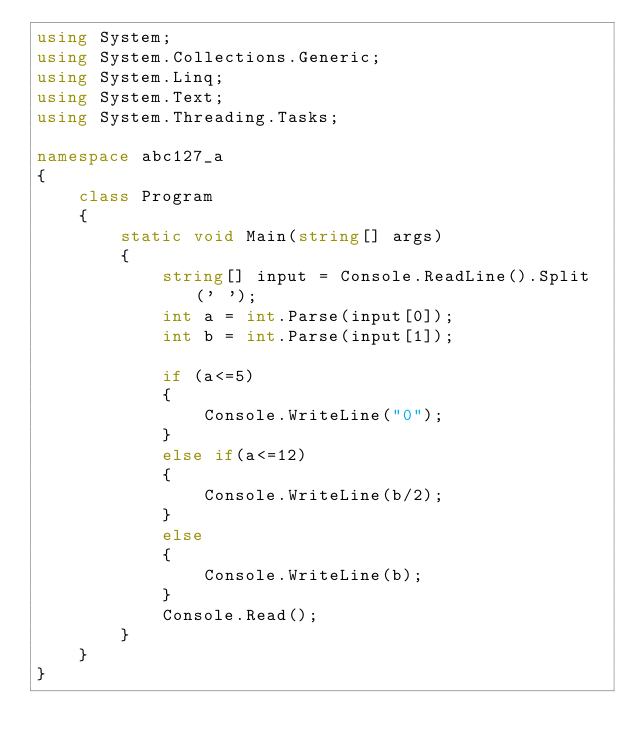<code> <loc_0><loc_0><loc_500><loc_500><_C#_>using System;
using System.Collections.Generic;
using System.Linq;
using System.Text;
using System.Threading.Tasks;

namespace abc127_a
{
    class Program
    {
        static void Main(string[] args)
        {         
            string[] input = Console.ReadLine().Split(' ');
            int a = int.Parse(input[0]);
            int b = int.Parse(input[1]);

            if (a<=5)
            {
                Console.WriteLine("0");
            }
            else if(a<=12)
            {
                Console.WriteLine(b/2);
            }
            else
            {
                Console.WriteLine(b);
            }
            Console.Read();
        }
    }
}
</code> 